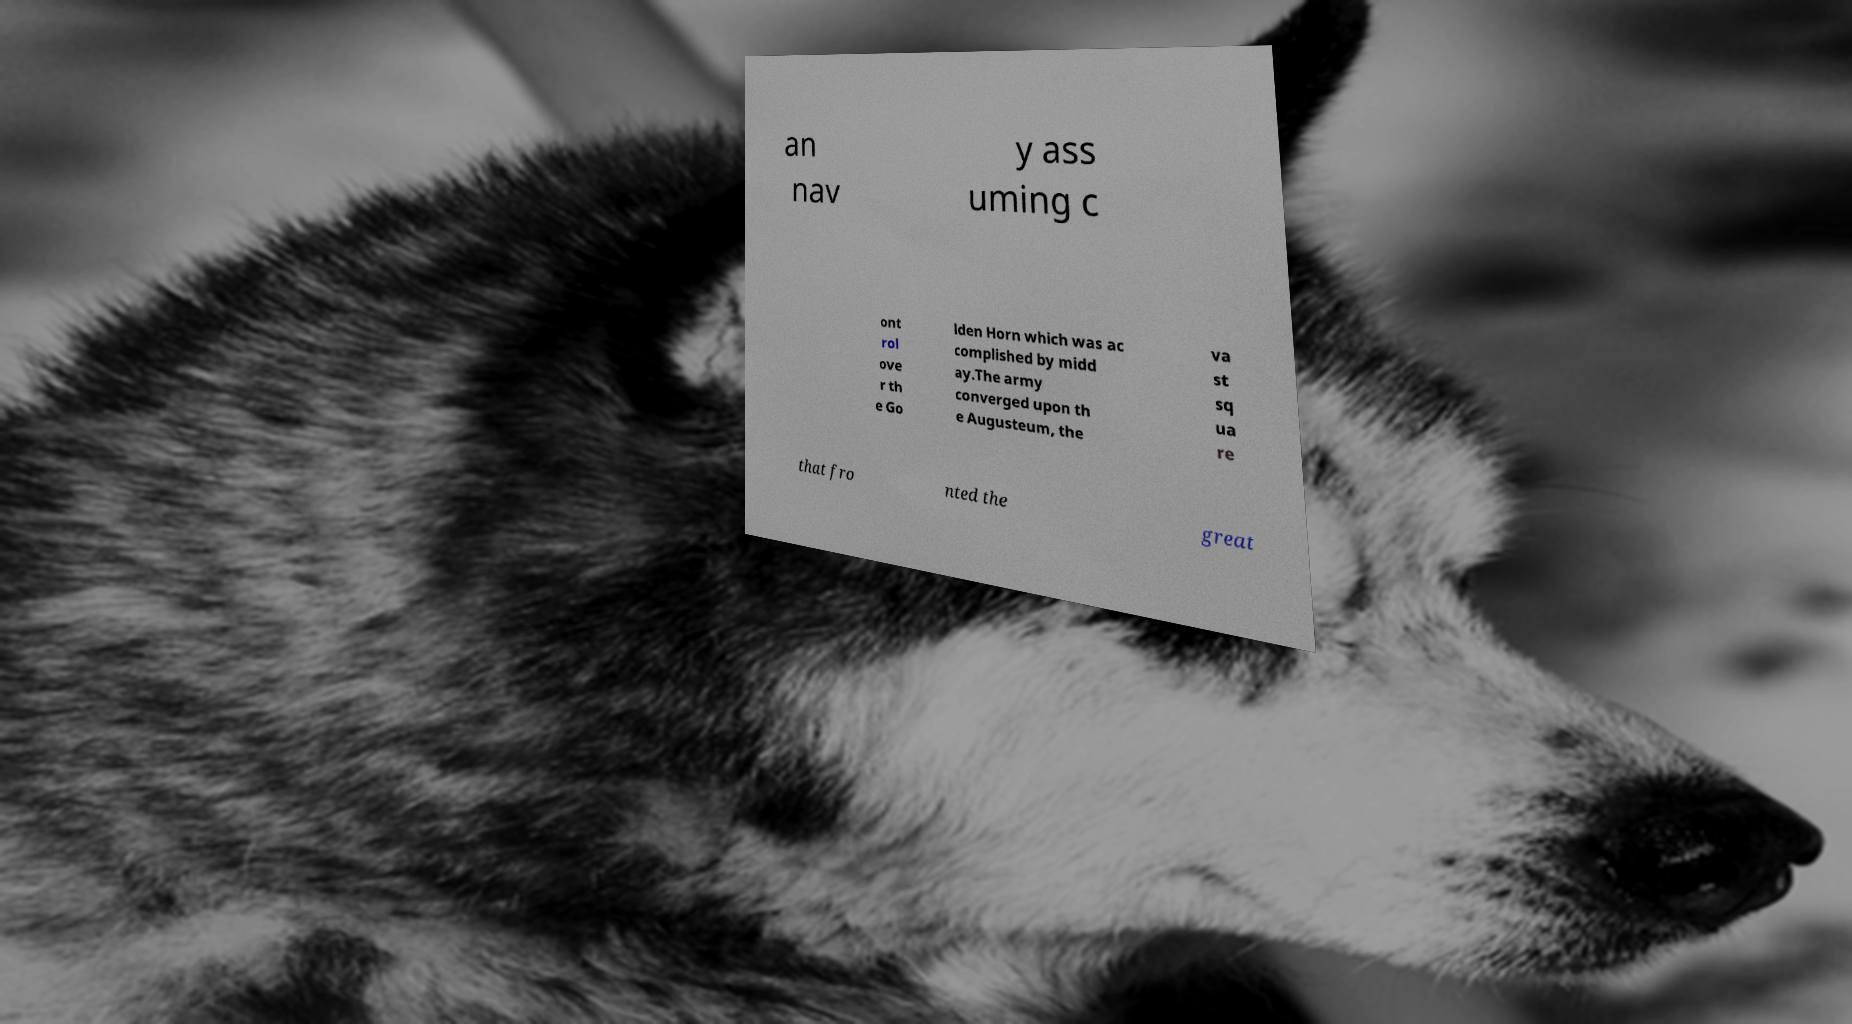What messages or text are displayed in this image? I need them in a readable, typed format. an nav y ass uming c ont rol ove r th e Go lden Horn which was ac complished by midd ay.The army converged upon th e Augusteum, the va st sq ua re that fro nted the great 